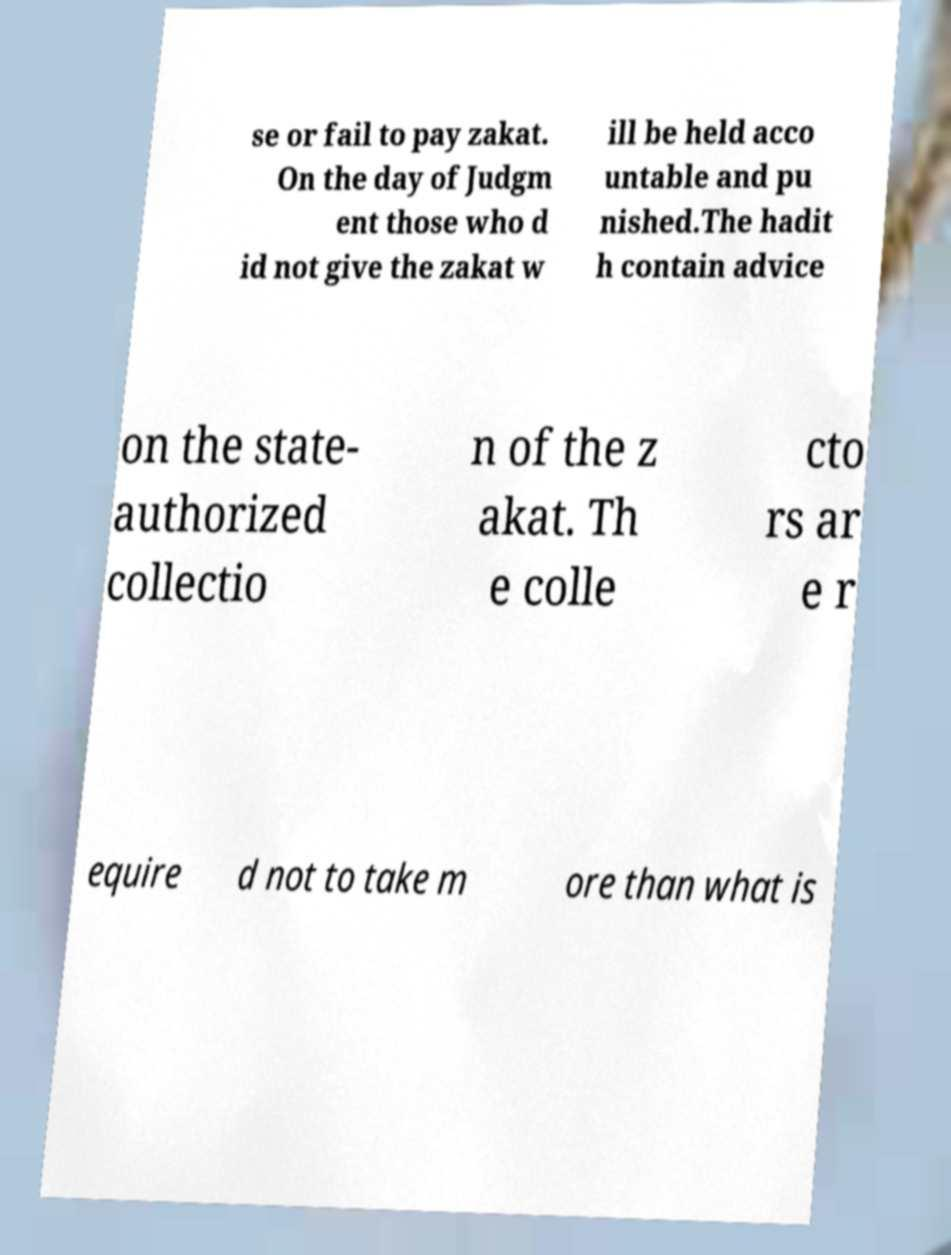What messages or text are displayed in this image? I need them in a readable, typed format. se or fail to pay zakat. On the day of Judgm ent those who d id not give the zakat w ill be held acco untable and pu nished.The hadit h contain advice on the state- authorized collectio n of the z akat. Th e colle cto rs ar e r equire d not to take m ore than what is 